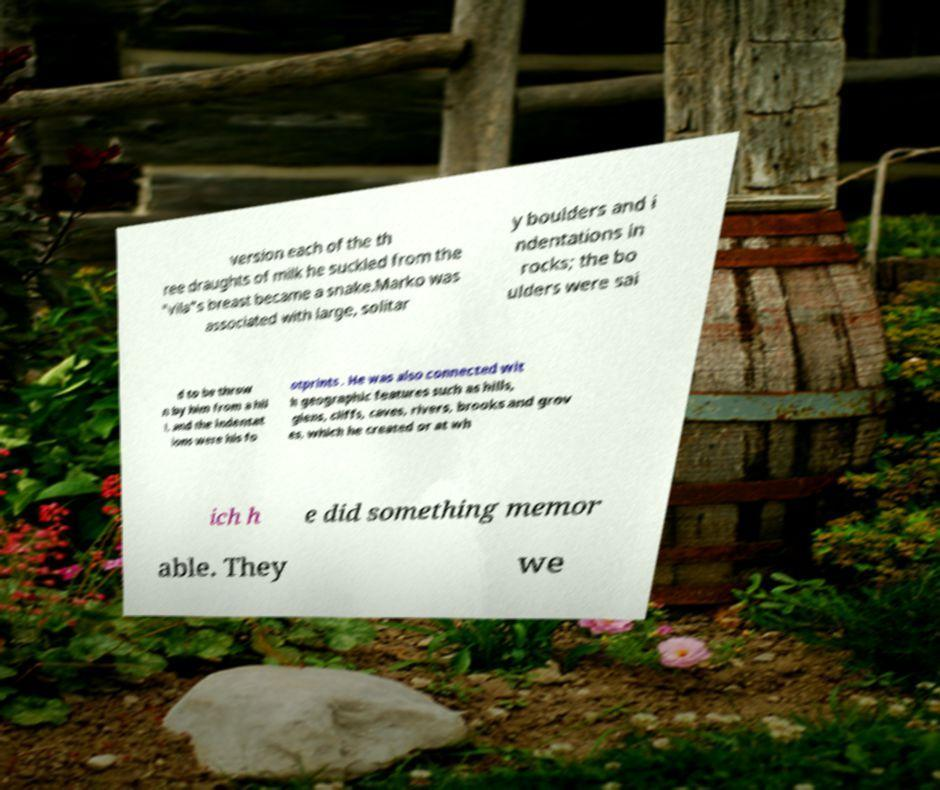Could you extract and type out the text from this image? version each of the th ree draughts of milk he suckled from the "vila"s breast became a snake.Marko was associated with large, solitar y boulders and i ndentations in rocks; the bo ulders were sai d to be throw n by him from a hil l, and the indentat ions were his fo otprints . He was also connected wit h geographic features such as hills, glens, cliffs, caves, rivers, brooks and grov es, which he created or at wh ich h e did something memor able. They we 